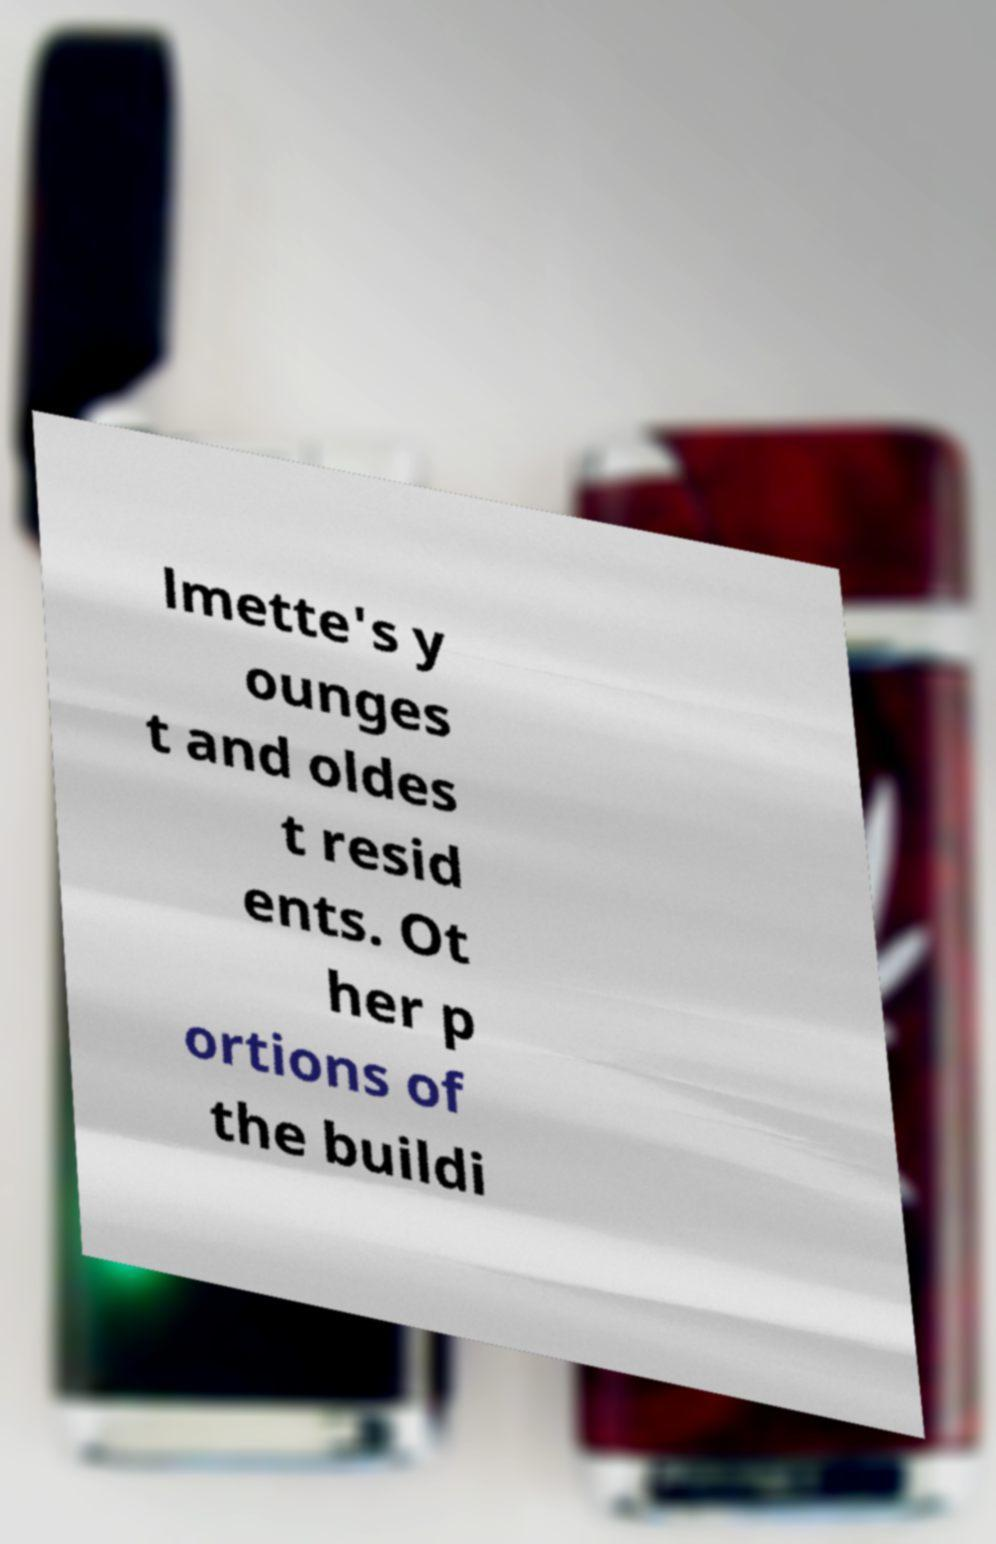Could you assist in decoding the text presented in this image and type it out clearly? lmette's y ounges t and oldes t resid ents. Ot her p ortions of the buildi 